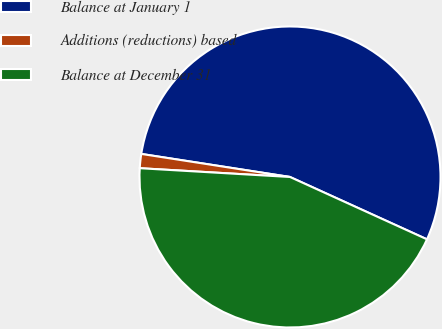Convert chart. <chart><loc_0><loc_0><loc_500><loc_500><pie_chart><fcel>Balance at January 1<fcel>Additions (reductions) based<fcel>Balance at December 31<nl><fcel>54.35%<fcel>1.52%<fcel>44.13%<nl></chart> 